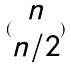Convert formula to latex. <formula><loc_0><loc_0><loc_500><loc_500>( \begin{matrix} n \\ n / 2 \end{matrix} )</formula> 